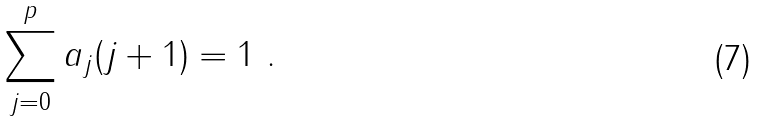<formula> <loc_0><loc_0><loc_500><loc_500>\sum _ { j = 0 } ^ { p } a _ { j } ( j + 1 ) = 1 \ .</formula> 